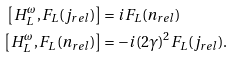<formula> <loc_0><loc_0><loc_500><loc_500>\left [ H _ { L } ^ { \omega } , F _ { L } ( j _ { r e l } ) \right ] & = i F _ { L } ( n _ { r e l } ) \\ \left [ H _ { L } ^ { \omega } , F _ { L } ( n _ { r e l } ) \right ] & = - i ( 2 \gamma ) ^ { 2 } F _ { L } ( j _ { r e l } ) .</formula> 